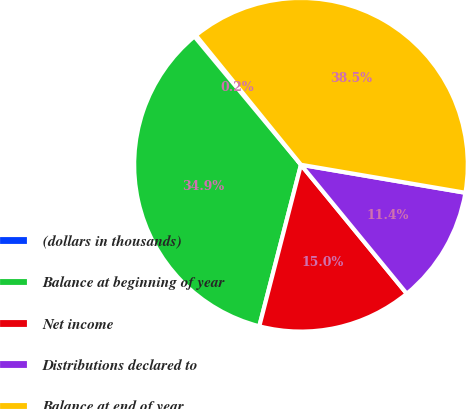Convert chart to OTSL. <chart><loc_0><loc_0><loc_500><loc_500><pie_chart><fcel>(dollars in thousands)<fcel>Balance at beginning of year<fcel>Net income<fcel>Distributions declared to<fcel>Balance at end of year<nl><fcel>0.18%<fcel>34.95%<fcel>14.96%<fcel>11.38%<fcel>38.54%<nl></chart> 